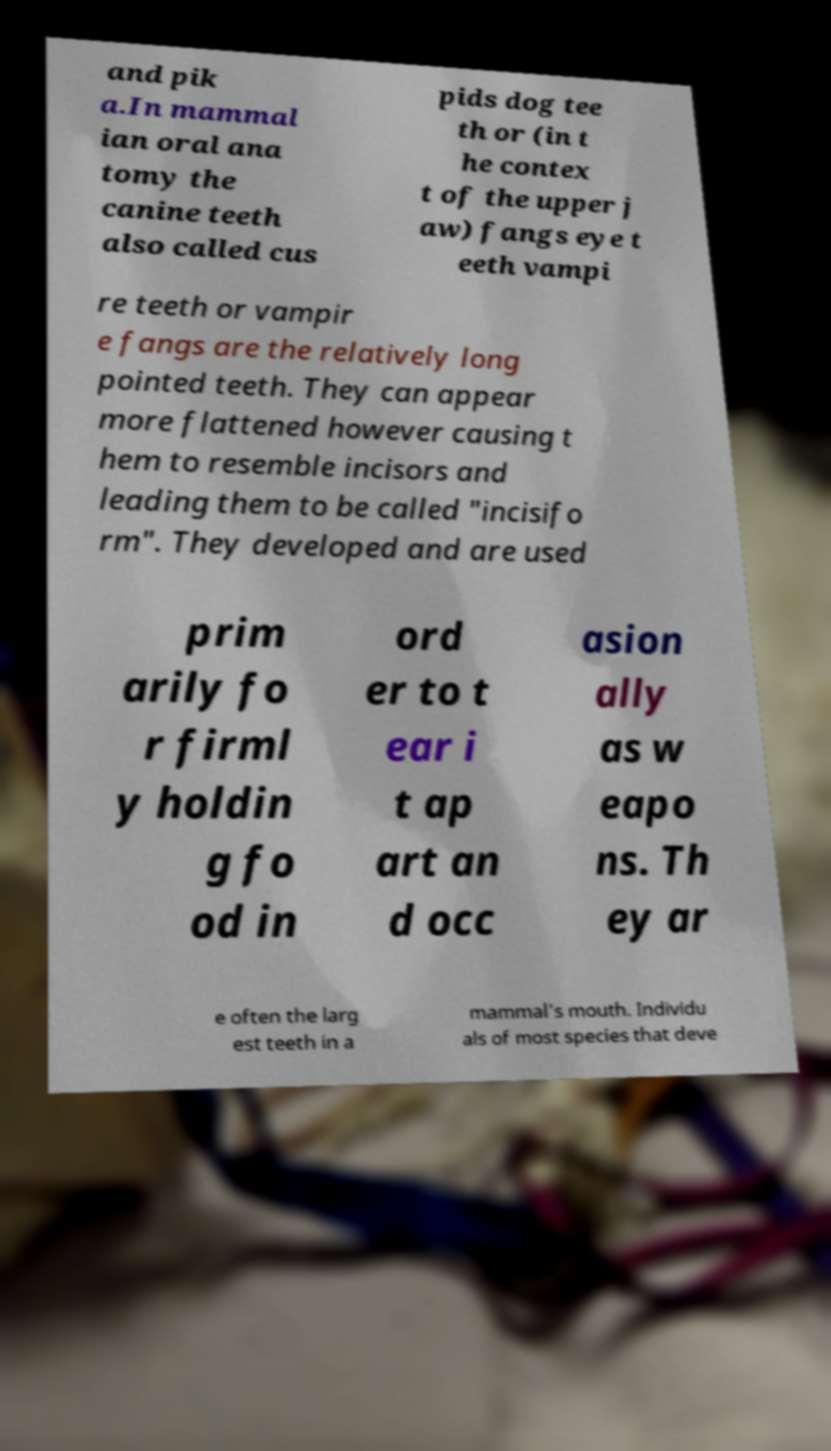Could you assist in decoding the text presented in this image and type it out clearly? and pik a.In mammal ian oral ana tomy the canine teeth also called cus pids dog tee th or (in t he contex t of the upper j aw) fangs eye t eeth vampi re teeth or vampir e fangs are the relatively long pointed teeth. They can appear more flattened however causing t hem to resemble incisors and leading them to be called "incisifo rm". They developed and are used prim arily fo r firml y holdin g fo od in ord er to t ear i t ap art an d occ asion ally as w eapo ns. Th ey ar e often the larg est teeth in a mammal's mouth. Individu als of most species that deve 